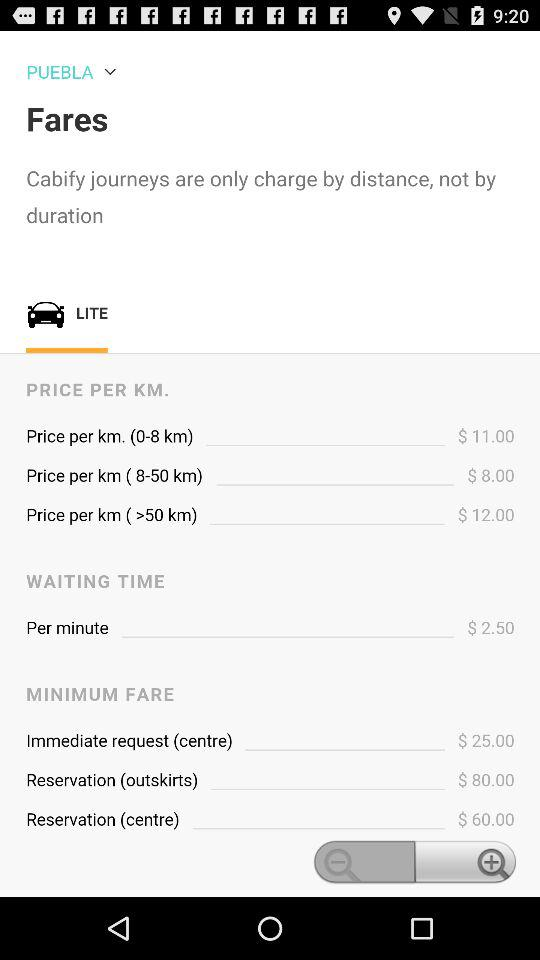What is the minimum fare for a reservation in the outskirts?
Answer the question using a single word or phrase. $80.00 